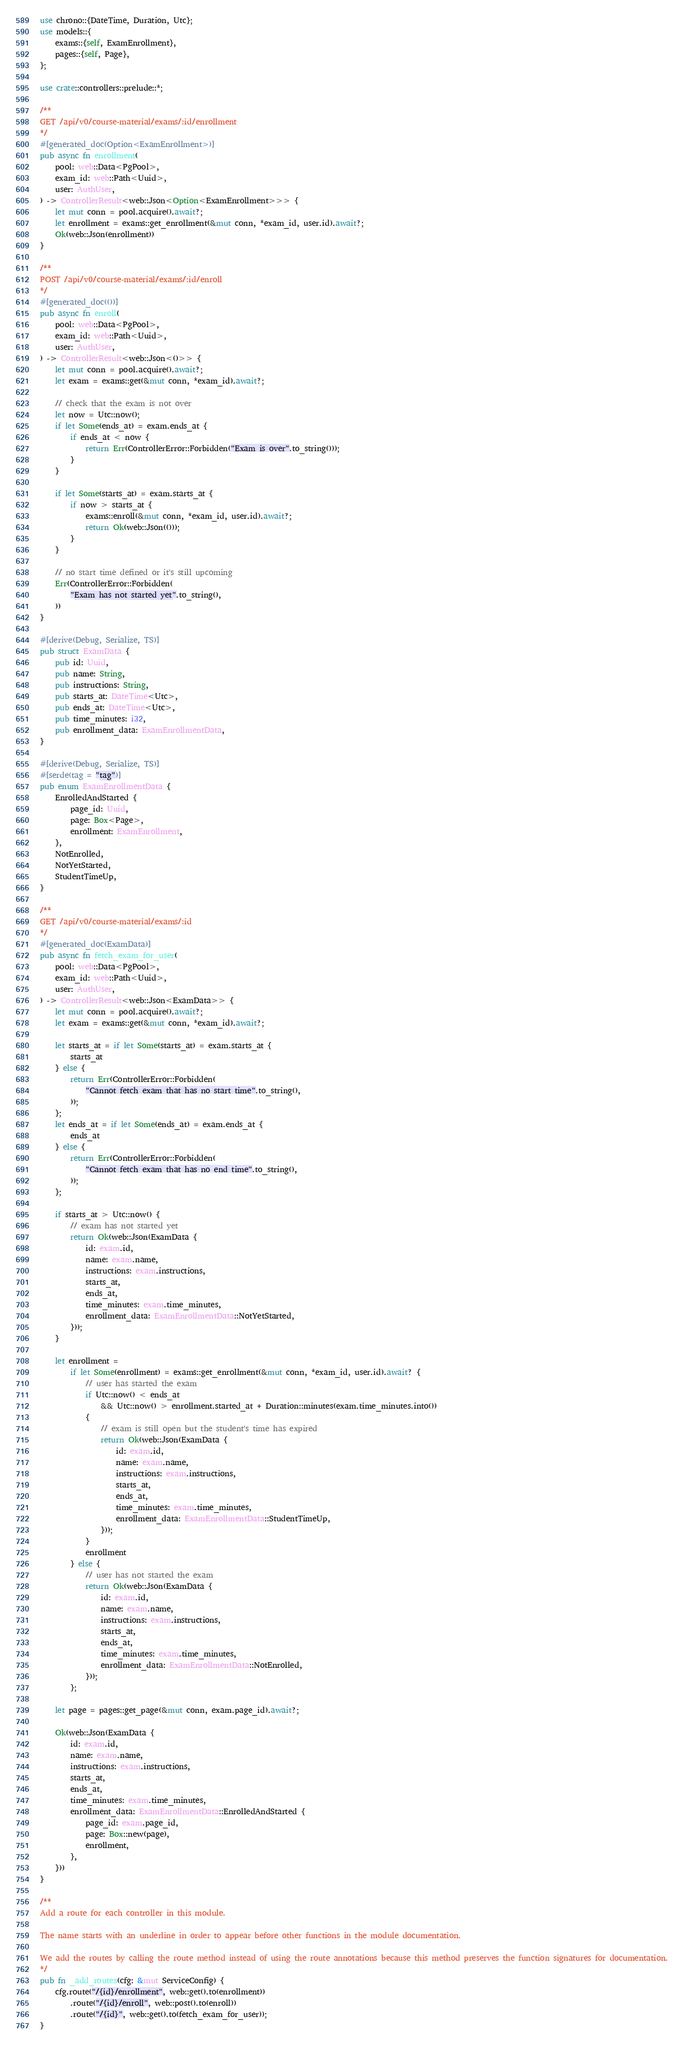Convert code to text. <code><loc_0><loc_0><loc_500><loc_500><_Rust_>use chrono::{DateTime, Duration, Utc};
use models::{
    exams::{self, ExamEnrollment},
    pages::{self, Page},
};

use crate::controllers::prelude::*;

/**
GET /api/v0/course-material/exams/:id/enrollment
*/
#[generated_doc(Option<ExamEnrollment>)]
pub async fn enrollment(
    pool: web::Data<PgPool>,
    exam_id: web::Path<Uuid>,
    user: AuthUser,
) -> ControllerResult<web::Json<Option<ExamEnrollment>>> {
    let mut conn = pool.acquire().await?;
    let enrollment = exams::get_enrollment(&mut conn, *exam_id, user.id).await?;
    Ok(web::Json(enrollment))
}

/**
POST /api/v0/course-material/exams/:id/enroll
*/
#[generated_doc(())]
pub async fn enroll(
    pool: web::Data<PgPool>,
    exam_id: web::Path<Uuid>,
    user: AuthUser,
) -> ControllerResult<web::Json<()>> {
    let mut conn = pool.acquire().await?;
    let exam = exams::get(&mut conn, *exam_id).await?;

    // check that the exam is not over
    let now = Utc::now();
    if let Some(ends_at) = exam.ends_at {
        if ends_at < now {
            return Err(ControllerError::Forbidden("Exam is over".to_string()));
        }
    }

    if let Some(starts_at) = exam.starts_at {
        if now > starts_at {
            exams::enroll(&mut conn, *exam_id, user.id).await?;
            return Ok(web::Json(()));
        }
    }

    // no start time defined or it's still upcoming
    Err(ControllerError::Forbidden(
        "Exam has not started yet".to_string(),
    ))
}

#[derive(Debug, Serialize, TS)]
pub struct ExamData {
    pub id: Uuid,
    pub name: String,
    pub instructions: String,
    pub starts_at: DateTime<Utc>,
    pub ends_at: DateTime<Utc>,
    pub time_minutes: i32,
    pub enrollment_data: ExamEnrollmentData,
}

#[derive(Debug, Serialize, TS)]
#[serde(tag = "tag")]
pub enum ExamEnrollmentData {
    EnrolledAndStarted {
        page_id: Uuid,
        page: Box<Page>,
        enrollment: ExamEnrollment,
    },
    NotEnrolled,
    NotYetStarted,
    StudentTimeUp,
}

/**
GET /api/v0/course-material/exams/:id
*/
#[generated_doc(ExamData)]
pub async fn fetch_exam_for_user(
    pool: web::Data<PgPool>,
    exam_id: web::Path<Uuid>,
    user: AuthUser,
) -> ControllerResult<web::Json<ExamData>> {
    let mut conn = pool.acquire().await?;
    let exam = exams::get(&mut conn, *exam_id).await?;

    let starts_at = if let Some(starts_at) = exam.starts_at {
        starts_at
    } else {
        return Err(ControllerError::Forbidden(
            "Cannot fetch exam that has no start time".to_string(),
        ));
    };
    let ends_at = if let Some(ends_at) = exam.ends_at {
        ends_at
    } else {
        return Err(ControllerError::Forbidden(
            "Cannot fetch exam that has no end time".to_string(),
        ));
    };

    if starts_at > Utc::now() {
        // exam has not started yet
        return Ok(web::Json(ExamData {
            id: exam.id,
            name: exam.name,
            instructions: exam.instructions,
            starts_at,
            ends_at,
            time_minutes: exam.time_minutes,
            enrollment_data: ExamEnrollmentData::NotYetStarted,
        }));
    }

    let enrollment =
        if let Some(enrollment) = exams::get_enrollment(&mut conn, *exam_id, user.id).await? {
            // user has started the exam
            if Utc::now() < ends_at
                && Utc::now() > enrollment.started_at + Duration::minutes(exam.time_minutes.into())
            {
                // exam is still open but the student's time has expired
                return Ok(web::Json(ExamData {
                    id: exam.id,
                    name: exam.name,
                    instructions: exam.instructions,
                    starts_at,
                    ends_at,
                    time_minutes: exam.time_minutes,
                    enrollment_data: ExamEnrollmentData::StudentTimeUp,
                }));
            }
            enrollment
        } else {
            // user has not started the exam
            return Ok(web::Json(ExamData {
                id: exam.id,
                name: exam.name,
                instructions: exam.instructions,
                starts_at,
                ends_at,
                time_minutes: exam.time_minutes,
                enrollment_data: ExamEnrollmentData::NotEnrolled,
            }));
        };

    let page = pages::get_page(&mut conn, exam.page_id).await?;

    Ok(web::Json(ExamData {
        id: exam.id,
        name: exam.name,
        instructions: exam.instructions,
        starts_at,
        ends_at,
        time_minutes: exam.time_minutes,
        enrollment_data: ExamEnrollmentData::EnrolledAndStarted {
            page_id: exam.page_id,
            page: Box::new(page),
            enrollment,
        },
    }))
}

/**
Add a route for each controller in this module.

The name starts with an underline in order to appear before other functions in the module documentation.

We add the routes by calling the route method instead of using the route annotations because this method preserves the function signatures for documentation.
*/
pub fn _add_routes(cfg: &mut ServiceConfig) {
    cfg.route("/{id}/enrollment", web::get().to(enrollment))
        .route("/{id}/enroll", web::post().to(enroll))
        .route("/{id}", web::get().to(fetch_exam_for_user));
}
</code> 